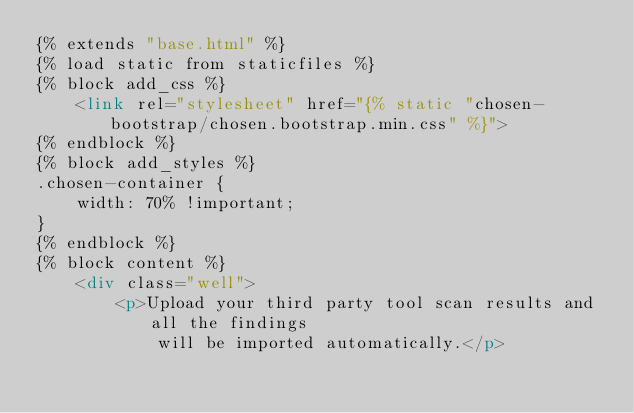<code> <loc_0><loc_0><loc_500><loc_500><_HTML_>{% extends "base.html" %}
{% load static from staticfiles %}
{% block add_css %}
    <link rel="stylesheet" href="{% static "chosen-bootstrap/chosen.bootstrap.min.css" %}">
{% endblock %}
{% block add_styles %}
.chosen-container {
    width: 70% !important;
}
{% endblock %}
{% block content %}
    <div class="well">
        <p>Upload your third party tool scan results and all the findings
            will be imported automatically.</p>
</code> 